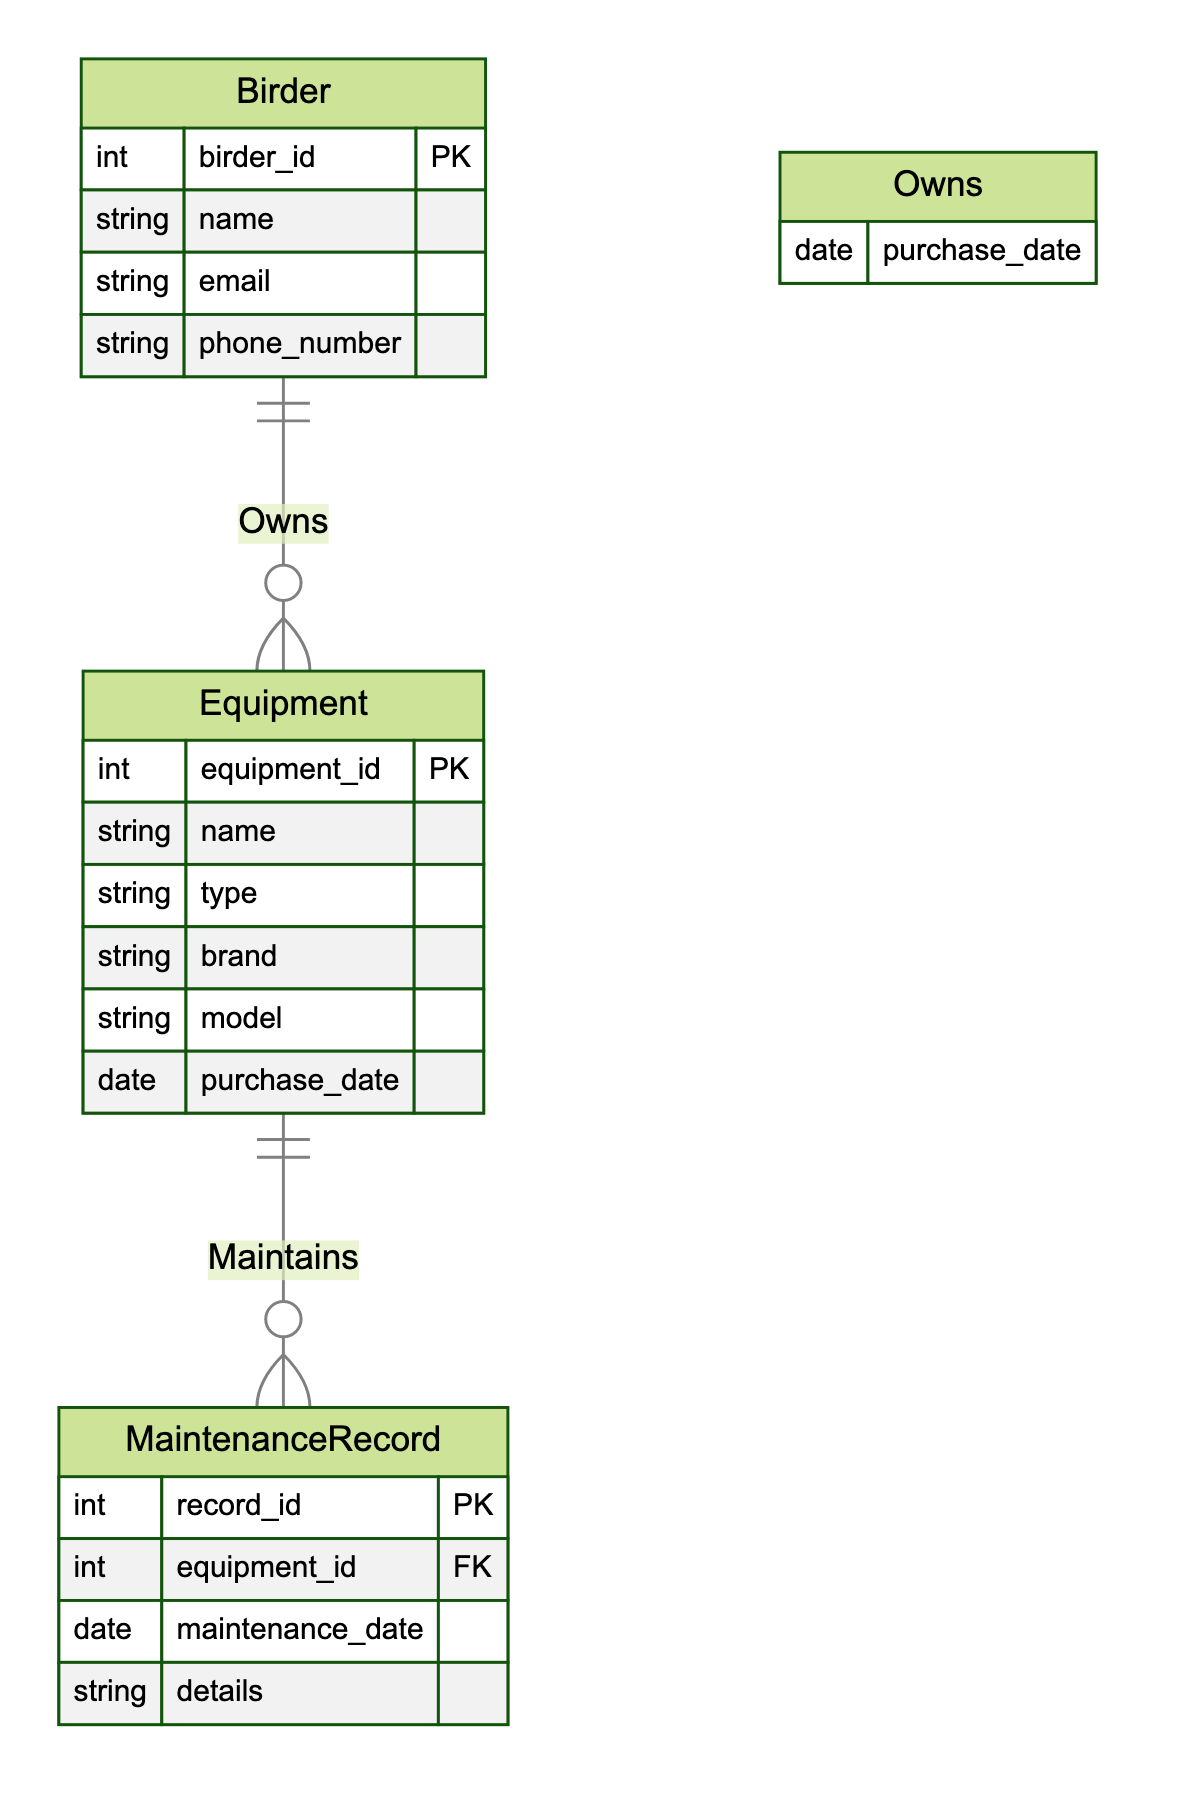What entities are present in the diagram? The diagram includes three entities which are Birder, Equipment, and MaintenanceRecord. Each entity represents a significant element in the context of bird-watching equipment and its management.
Answer: Birder, Equipment, MaintenanceRecord How many relationships exist in the diagram? The diagram features two relationships: Owns and Maintains. Relationships describe how the entities interact with one another.
Answer: 2 What is the relationship between Birder and Equipment? The relationship between Birder and Equipment is defined as "Owns". This indicates that each Birder can own multiple pieces of Equipment.
Answer: Owns What attribute connects MaintenanceRecord to Equipment? The attribute connecting MaintenanceRecord to Equipment is equipment_id, which is a foreign key in the MaintenanceRecord that references the Equipment.
Answer: equipment_id How many attributes does the Equipment entity have? The Equipment entity has six attributes: equipment_id, name, type, brand, model, and purchase_date. Attributes are details that provide more information about the entity.
Answer: 6 What type of relationship is Maintains? The Maintains relationship is a one-to-many relationship, meaning one Equipment can be linked to multiple MaintenanceRecords. This reflects maintenance history tied to specific equipment.
Answer: one-to-many Which entity holds the contact information of the birders? The entity that holds the contact information of the birders is the Birder entity, which includes attributes such as email and phone_number.
Answer: Birder What is the purpose of the purchase_date attribute in the Owns relationship? The purchase_date attribute in the Owns relationship is intended to record when the Birder acquired the Equipment, indicating the ownership date.
Answer: Record ownership date 